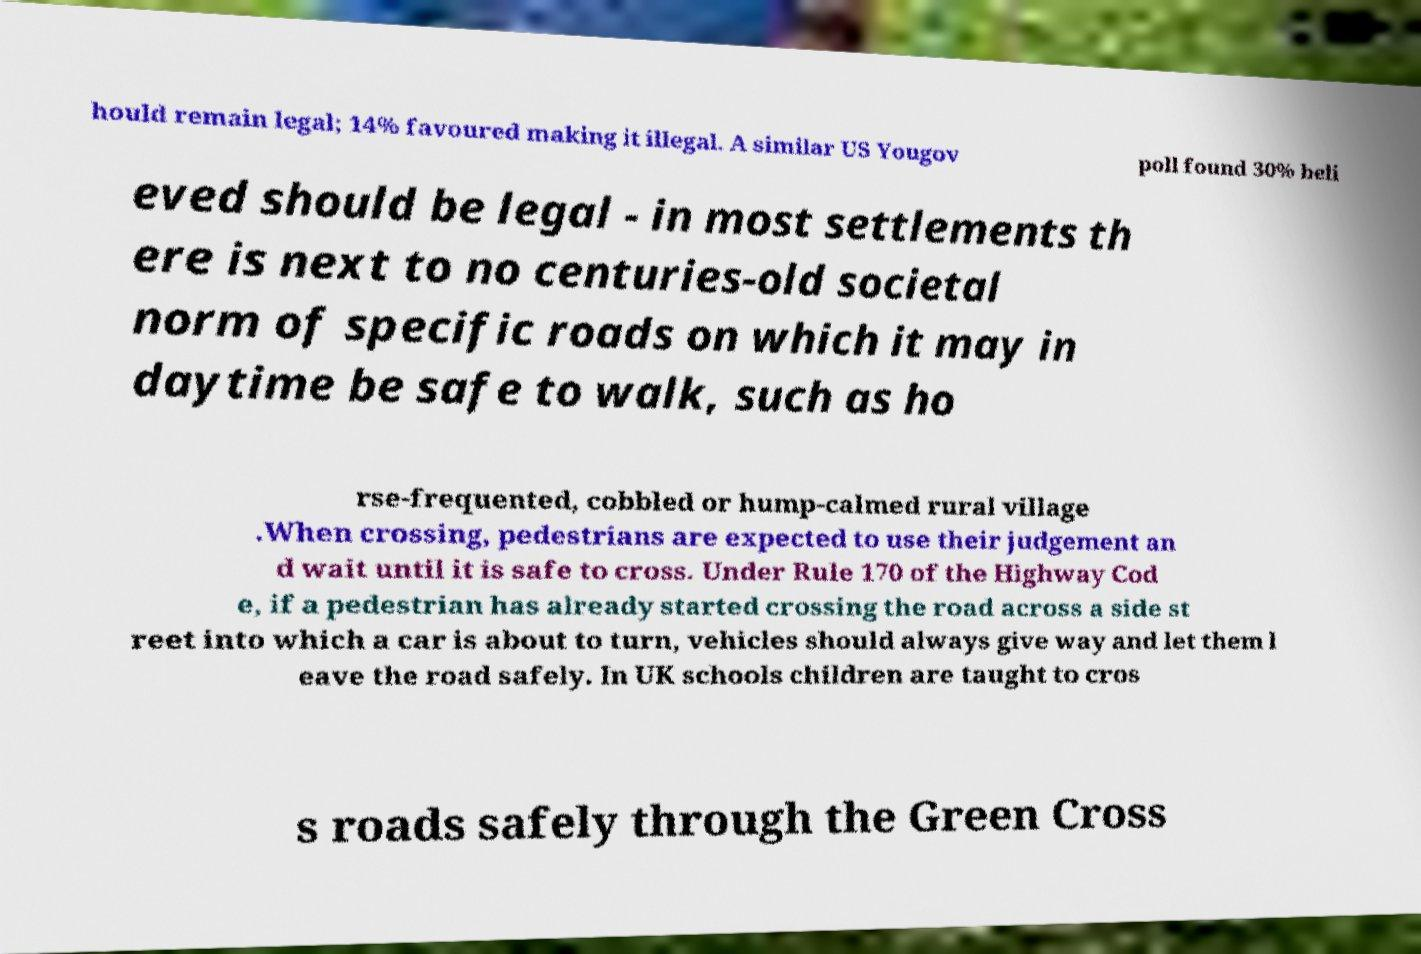Can you read and provide the text displayed in the image?This photo seems to have some interesting text. Can you extract and type it out for me? hould remain legal; 14% favoured making it illegal. A similar US Yougov poll found 30% beli eved should be legal - in most settlements th ere is next to no centuries-old societal norm of specific roads on which it may in daytime be safe to walk, such as ho rse-frequented, cobbled or hump-calmed rural village .When crossing, pedestrians are expected to use their judgement an d wait until it is safe to cross. Under Rule 170 of the Highway Cod e, if a pedestrian has already started crossing the road across a side st reet into which a car is about to turn, vehicles should always give way and let them l eave the road safely. In UK schools children are taught to cros s roads safely through the Green Cross 